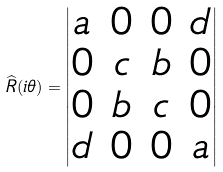<formula> <loc_0><loc_0><loc_500><loc_500>\widehat { R } ( i \theta ) = \begin{vmatrix} a & 0 & 0 & d \\ 0 & c & b & 0 \\ 0 & b & c & 0 \\ d & 0 & 0 & a \end{vmatrix}</formula> 